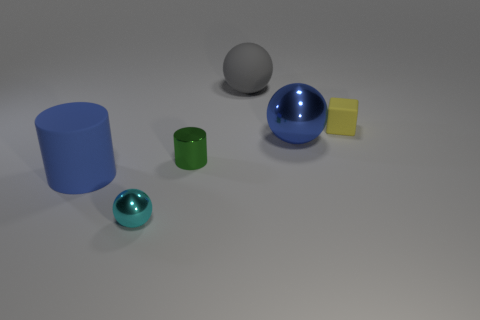Subtract all red blocks. Subtract all blue spheres. How many blocks are left? 1 Add 3 yellow matte objects. How many objects exist? 9 Subtract all blocks. How many objects are left? 5 Add 1 green objects. How many green objects exist? 2 Subtract 1 green cylinders. How many objects are left? 5 Subtract all gray objects. Subtract all tiny shiny things. How many objects are left? 3 Add 3 small yellow rubber blocks. How many small yellow rubber blocks are left? 4 